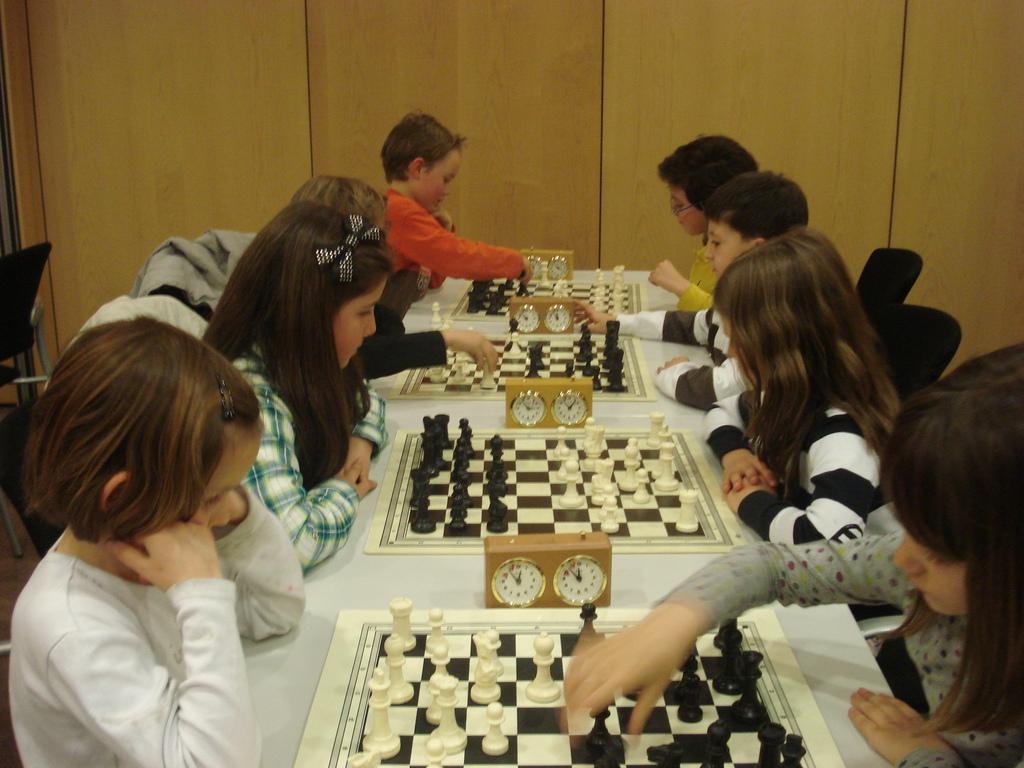Please provide a concise description of this image. In this image there are children who are playing chess. There is a table on which there are four chess board with chess coins on it. There is clock in between two chess boards. At the background there is wooden wall. 